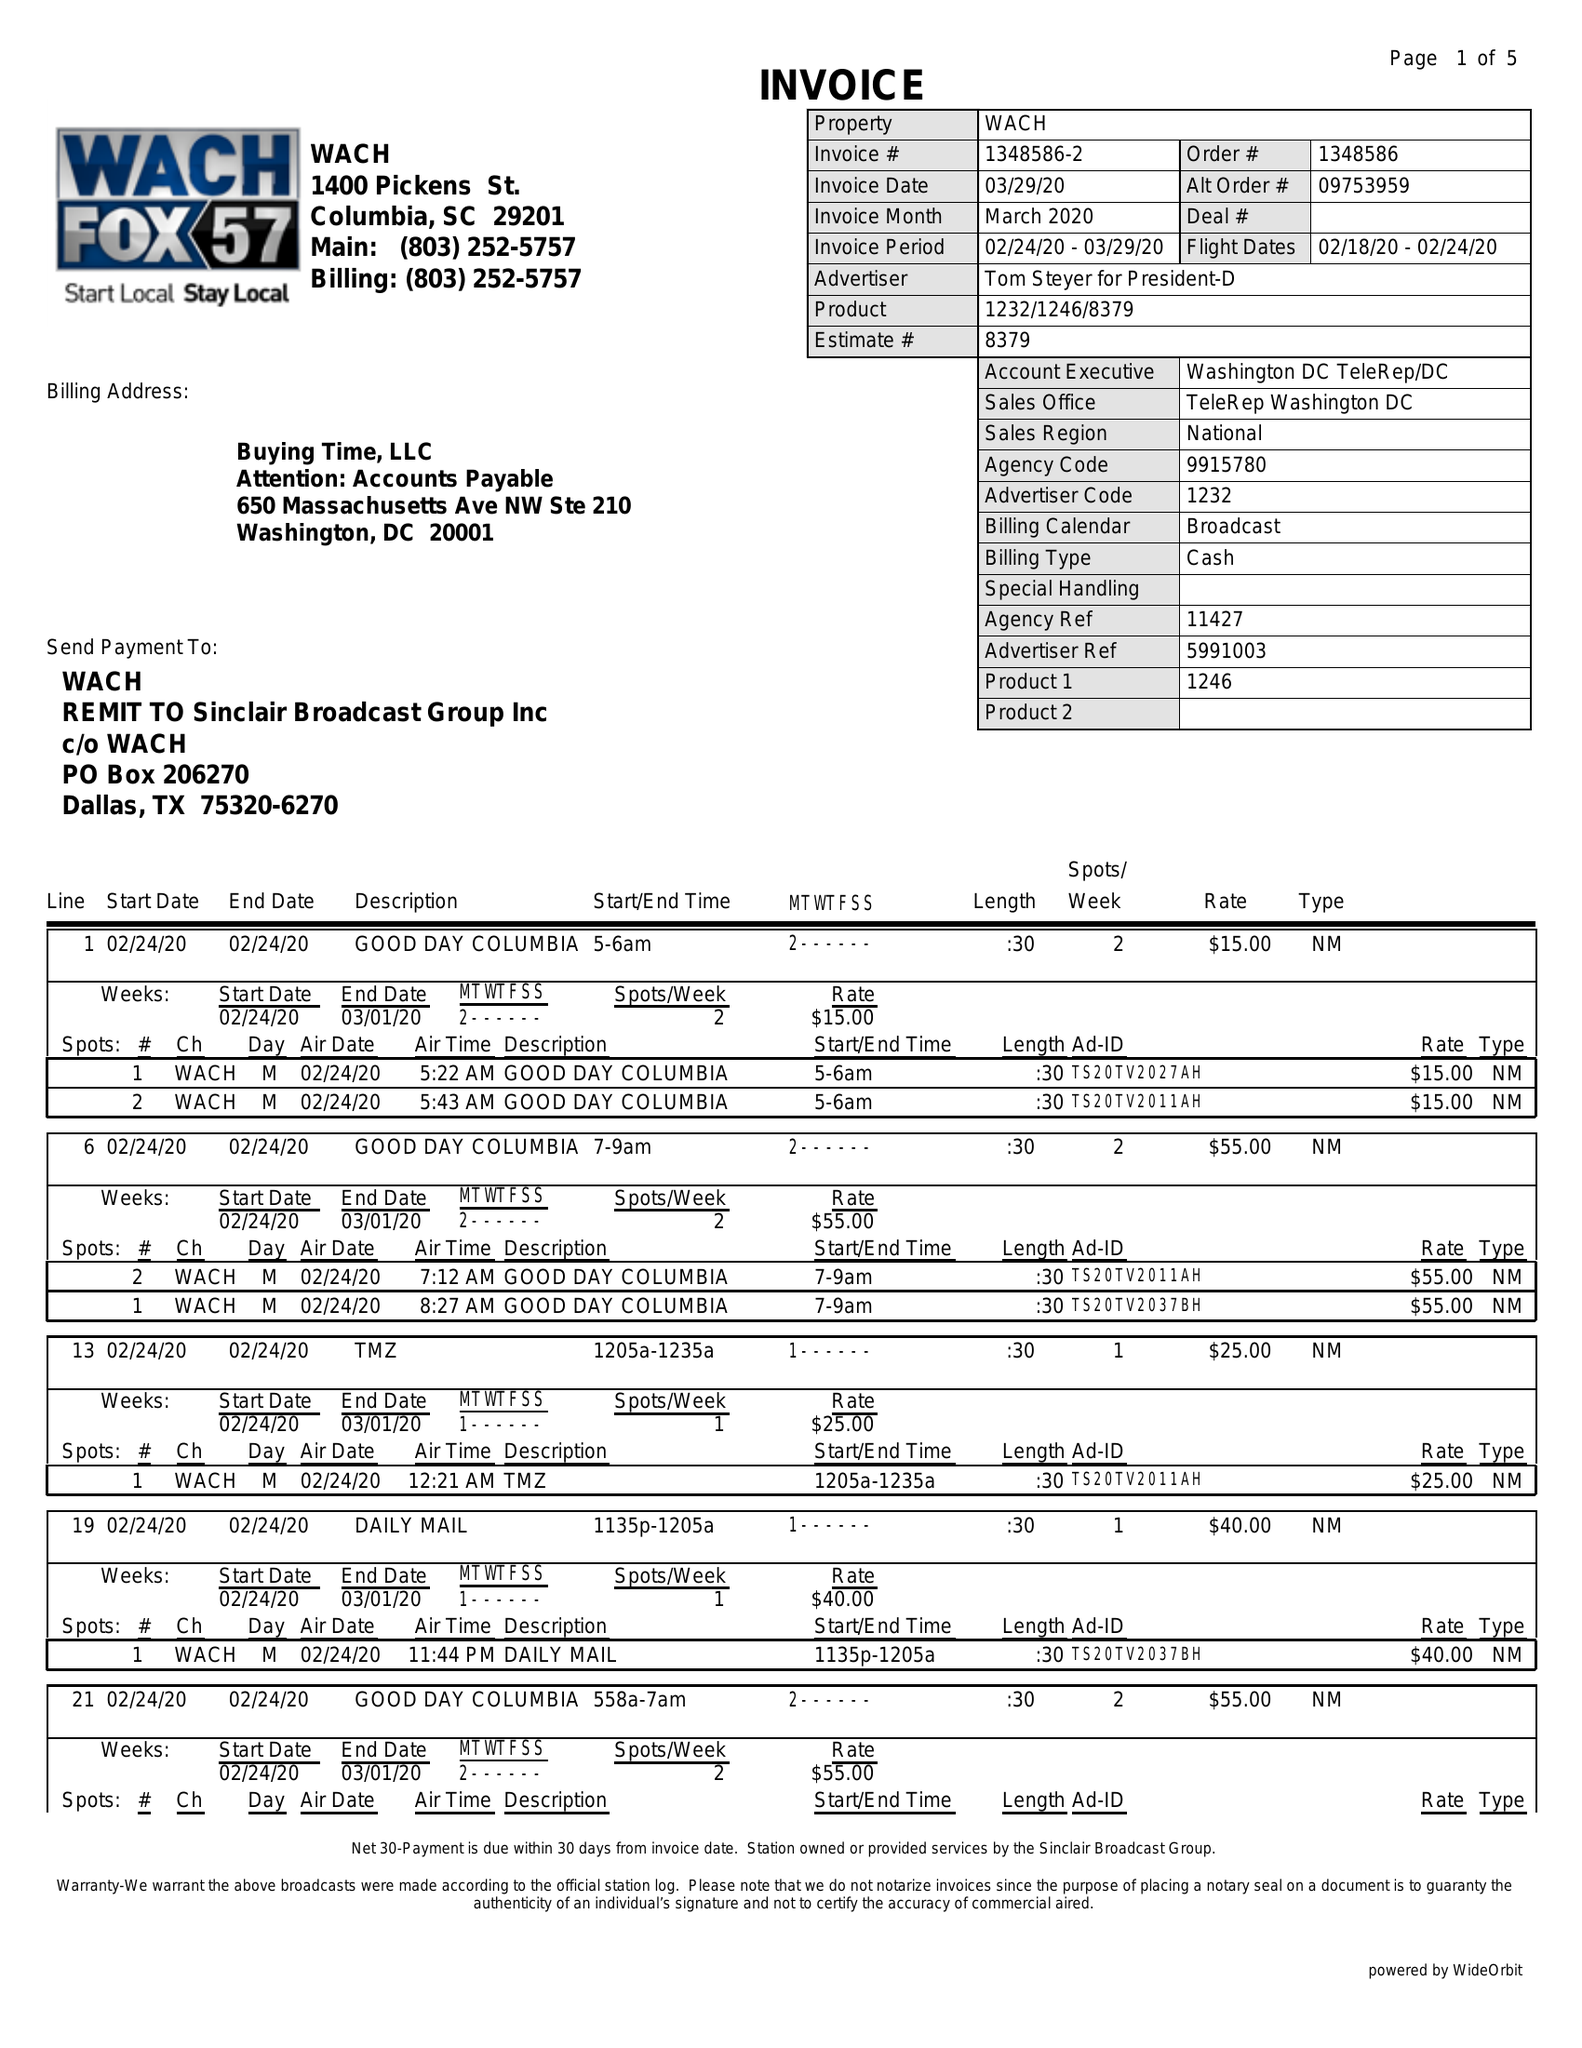What is the value for the flight_to?
Answer the question using a single word or phrase. 02/24/20 